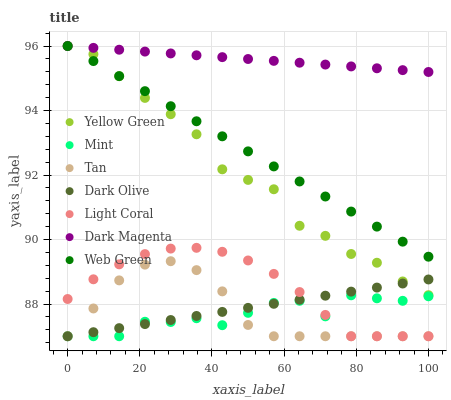Does Mint have the minimum area under the curve?
Answer yes or no. Yes. Does Dark Magenta have the maximum area under the curve?
Answer yes or no. Yes. Does Dark Olive have the minimum area under the curve?
Answer yes or no. No. Does Dark Olive have the maximum area under the curve?
Answer yes or no. No. Is Dark Magenta the smoothest?
Answer yes or no. Yes. Is Mint the roughest?
Answer yes or no. Yes. Is Dark Olive the smoothest?
Answer yes or no. No. Is Dark Olive the roughest?
Answer yes or no. No. Does Dark Olive have the lowest value?
Answer yes or no. Yes. Does Web Green have the lowest value?
Answer yes or no. No. Does Dark Magenta have the highest value?
Answer yes or no. Yes. Does Dark Olive have the highest value?
Answer yes or no. No. Is Light Coral less than Web Green?
Answer yes or no. Yes. Is Dark Magenta greater than Light Coral?
Answer yes or no. Yes. Does Tan intersect Dark Olive?
Answer yes or no. Yes. Is Tan less than Dark Olive?
Answer yes or no. No. Is Tan greater than Dark Olive?
Answer yes or no. No. Does Light Coral intersect Web Green?
Answer yes or no. No. 